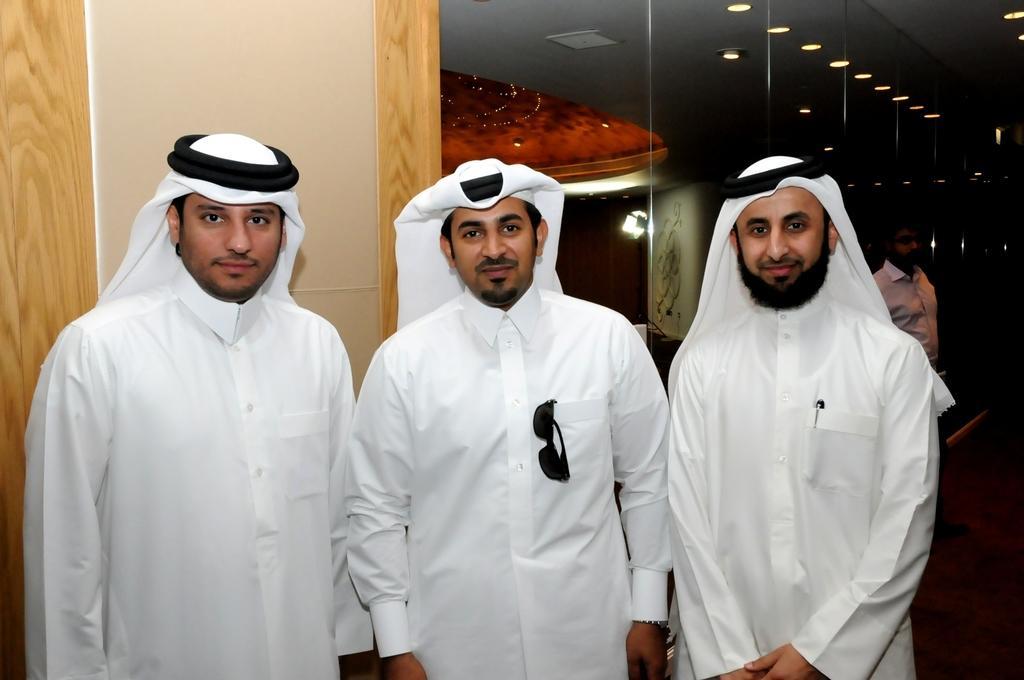Please provide a concise description of this image. In this image I see 4 men in which these 3 men are wearing white color dress and I see that these both of them are smiling and I see black color shades over here and I see the wall. In the background I see the lights on the ceiling and I see that it is dark over here. 